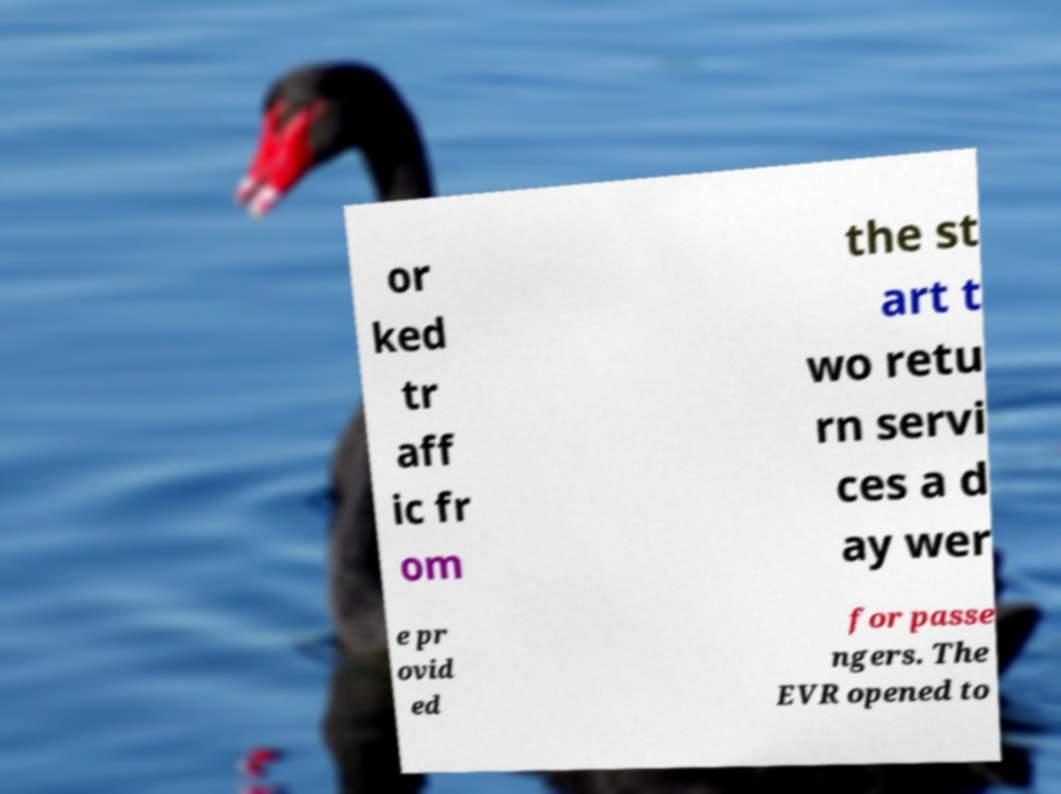There's text embedded in this image that I need extracted. Can you transcribe it verbatim? or ked tr aff ic fr om the st art t wo retu rn servi ces a d ay wer e pr ovid ed for passe ngers. The EVR opened to 